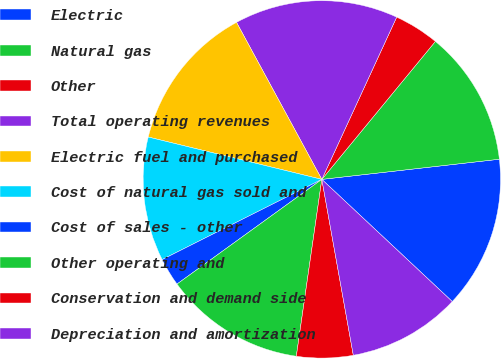<chart> <loc_0><loc_0><loc_500><loc_500><pie_chart><fcel>Electric<fcel>Natural gas<fcel>Other<fcel>Total operating revenues<fcel>Electric fuel and purchased<fcel>Cost of natural gas sold and<fcel>Cost of sales - other<fcel>Other operating and<fcel>Conservation and demand side<fcel>Depreciation and amortization<nl><fcel>13.78%<fcel>12.24%<fcel>4.08%<fcel>14.8%<fcel>13.27%<fcel>11.22%<fcel>2.55%<fcel>12.76%<fcel>5.1%<fcel>10.2%<nl></chart> 